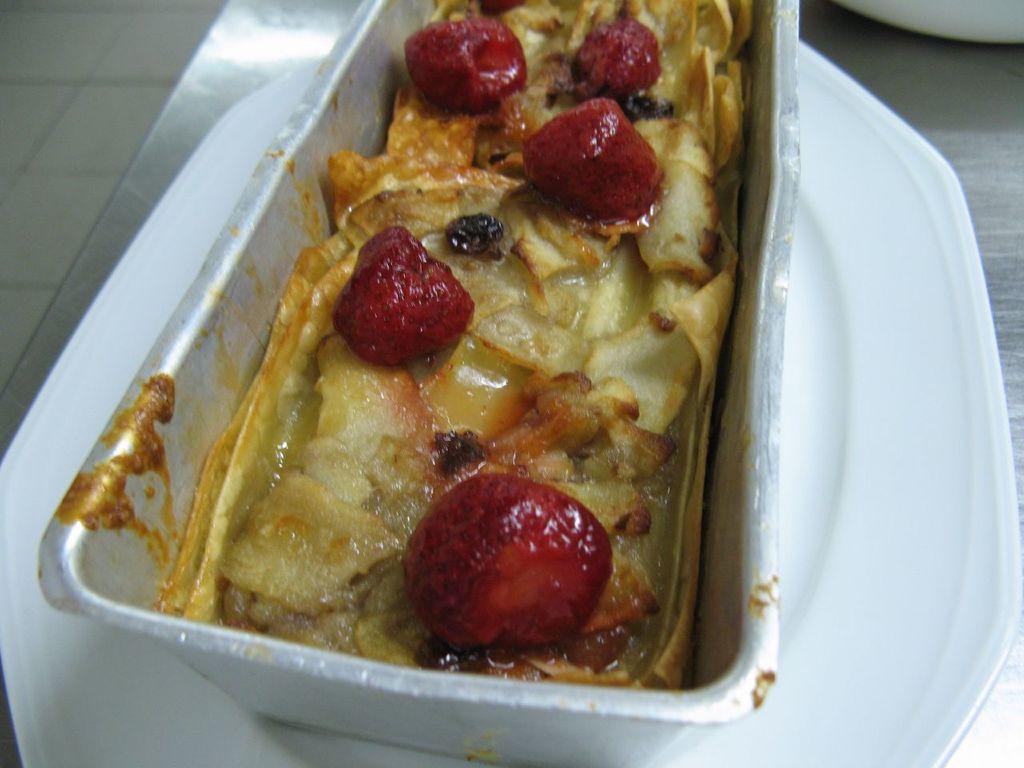Could you give a brief overview of what you see in this image? In this image in the center there is one plate, on the plate there is one box and in that box there is some food and at the bottom there is a table. 